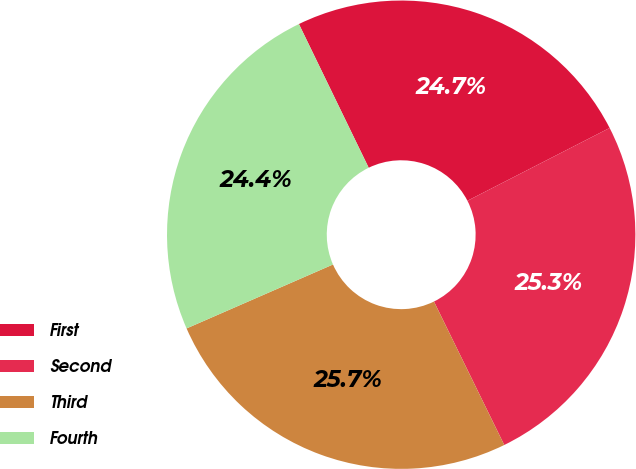Convert chart. <chart><loc_0><loc_0><loc_500><loc_500><pie_chart><fcel>First<fcel>Second<fcel>Third<fcel>Fourth<nl><fcel>24.66%<fcel>25.28%<fcel>25.7%<fcel>24.36%<nl></chart> 